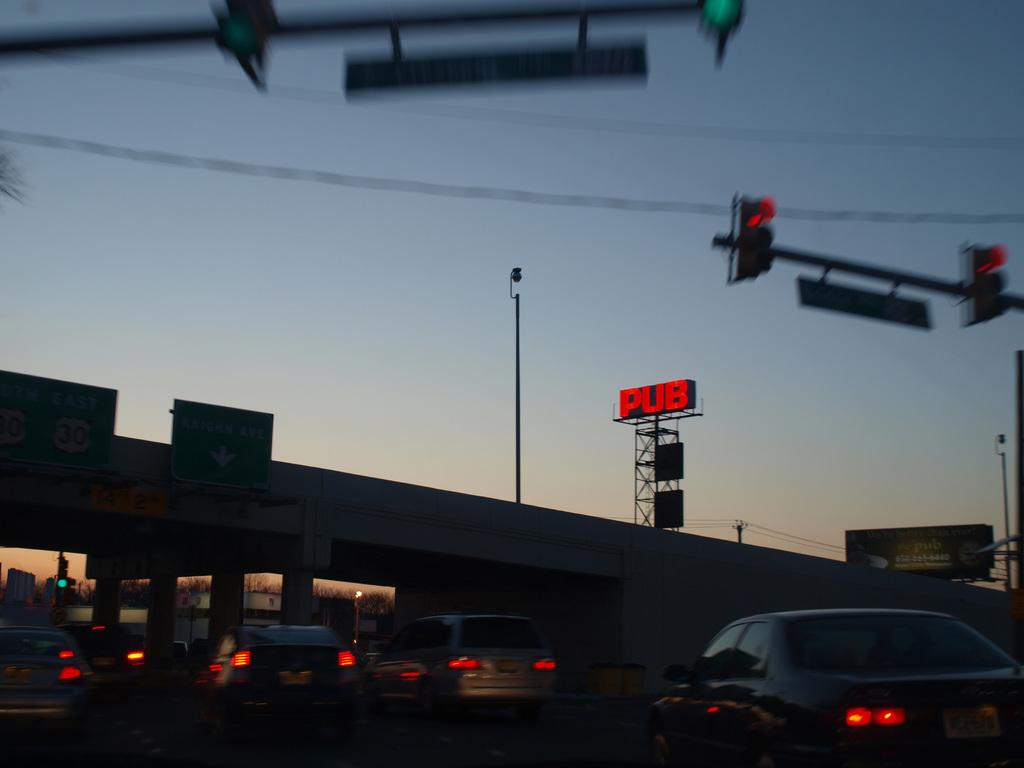What is the billboard advertising?
Ensure brevity in your answer.  Pub. 